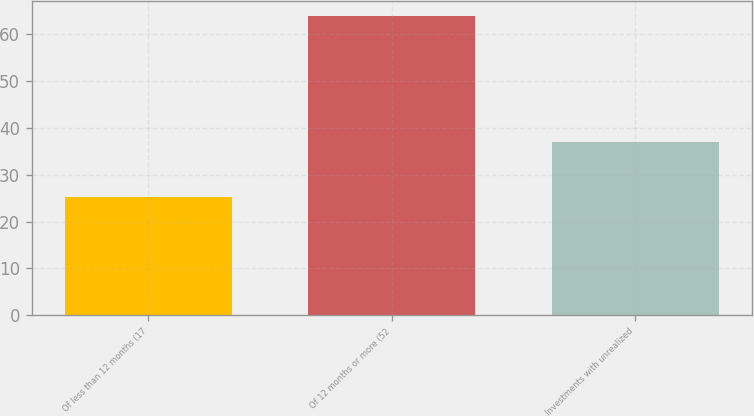Convert chart. <chart><loc_0><loc_0><loc_500><loc_500><bar_chart><fcel>Of less than 12 months (17<fcel>Of 12 months or more (52<fcel>Investments with unrealized<nl><fcel>25.3<fcel>63.9<fcel>37<nl></chart> 